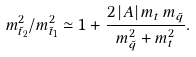<formula> <loc_0><loc_0><loc_500><loc_500>m ^ { 2 } _ { \tilde { t } _ { 2 } } / m ^ { 2 } _ { \tilde { t } _ { 1 } } \simeq 1 + \frac { 2 \, | A | \, m _ { t } \, m _ { \tilde { q } } } { m ^ { 2 } _ { \tilde { q } } + m ^ { 2 } _ { t } } .</formula> 